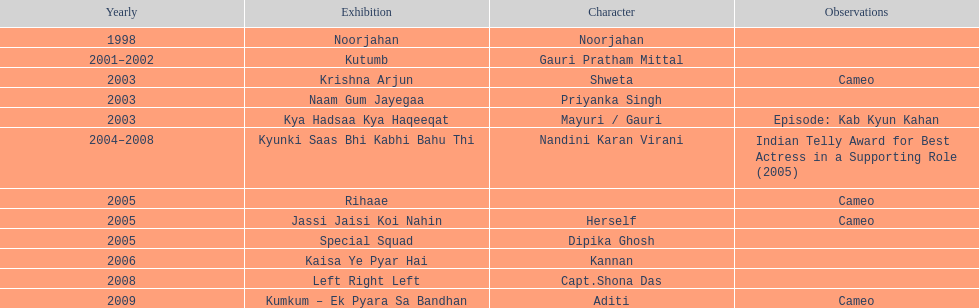Which was the only television show gauri starred in, in which she played herself? Jassi Jaisi Koi Nahin. 